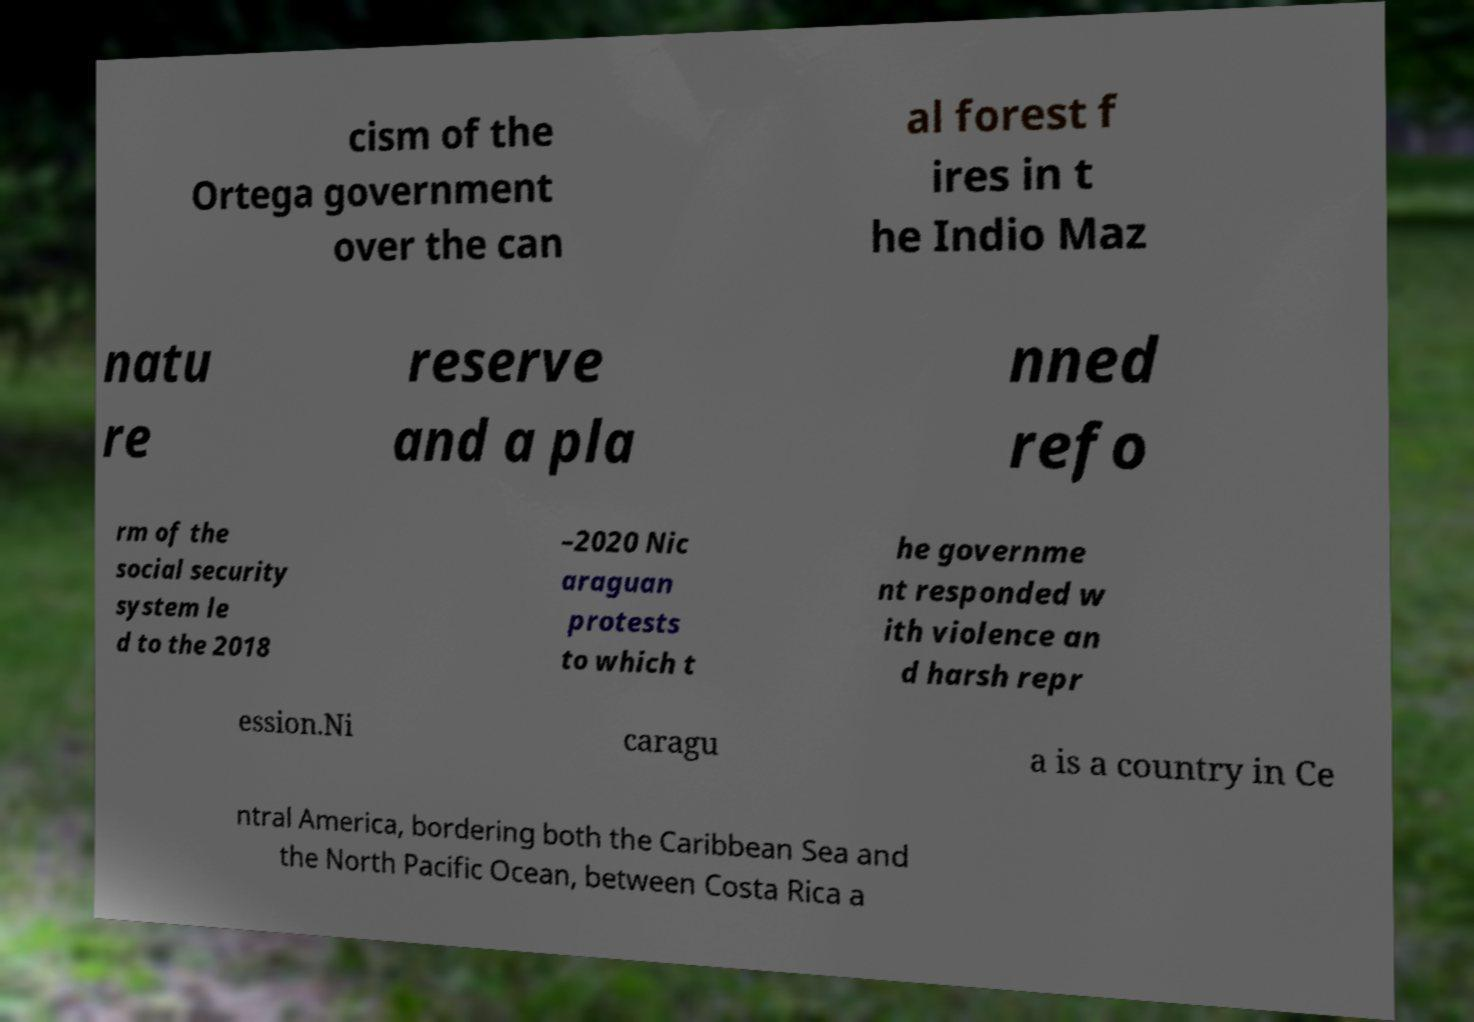What messages or text are displayed in this image? I need them in a readable, typed format. cism of the Ortega government over the can al forest f ires in t he Indio Maz natu re reserve and a pla nned refo rm of the social security system le d to the 2018 –2020 Nic araguan protests to which t he governme nt responded w ith violence an d harsh repr ession.Ni caragu a is a country in Ce ntral America, bordering both the Caribbean Sea and the North Pacific Ocean, between Costa Rica a 